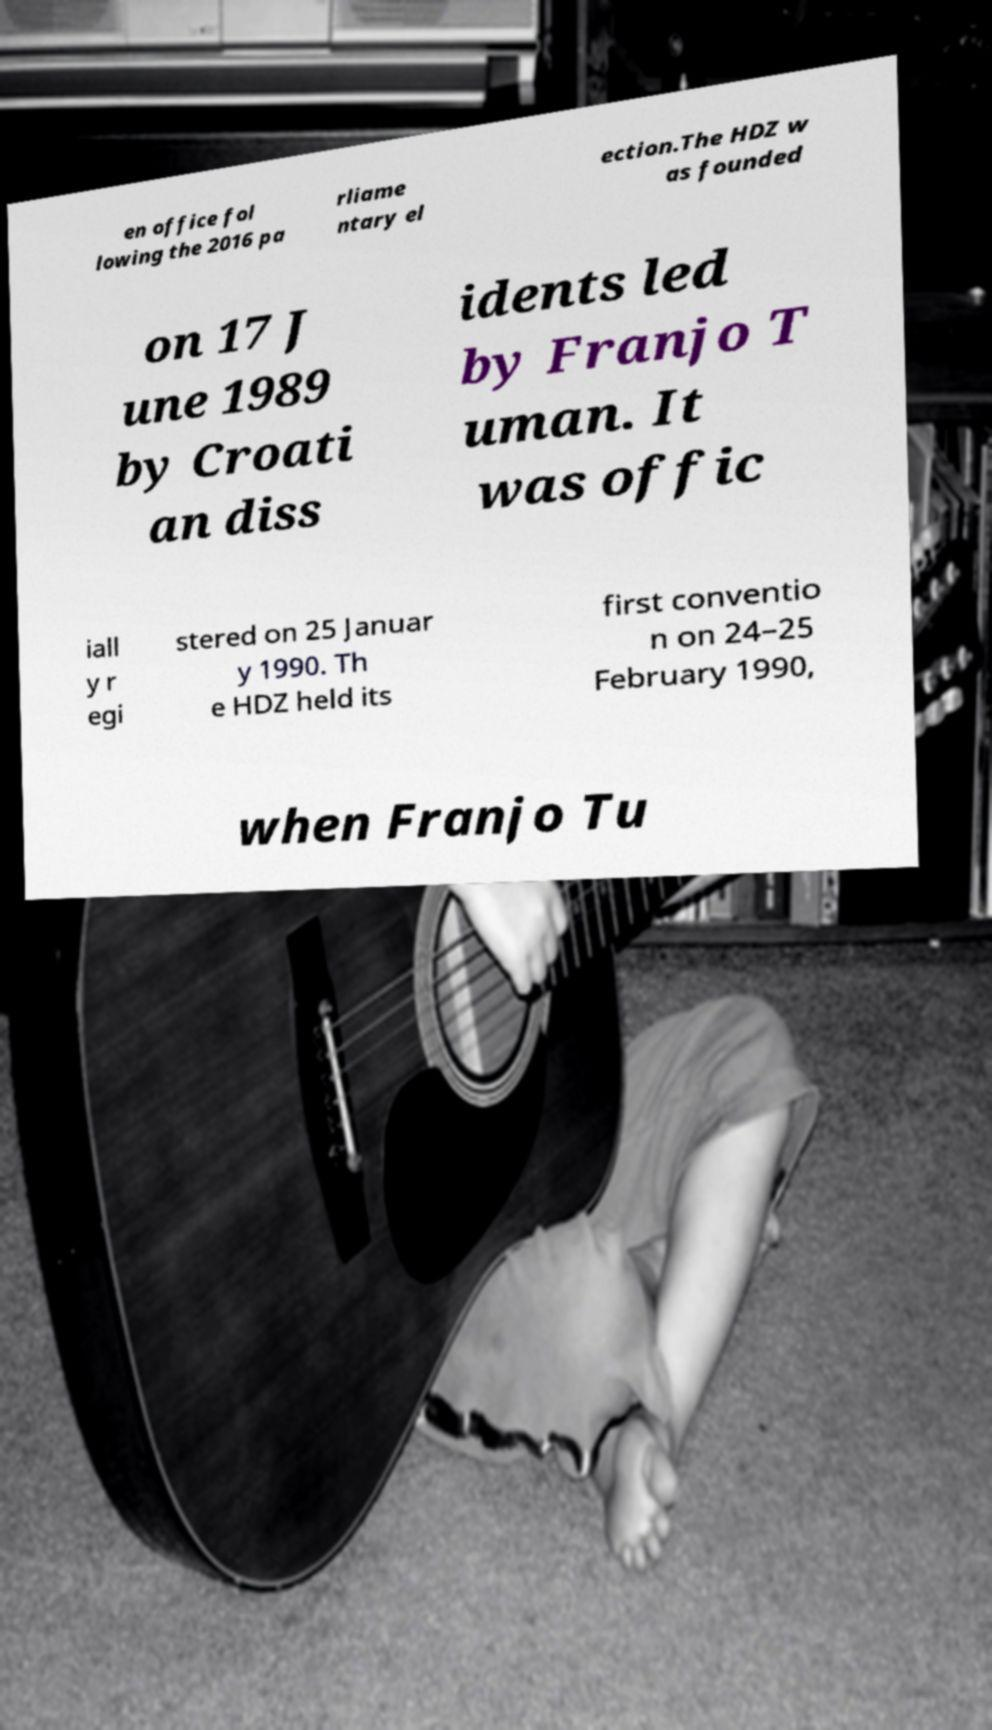Could you assist in decoding the text presented in this image and type it out clearly? en office fol lowing the 2016 pa rliame ntary el ection.The HDZ w as founded on 17 J une 1989 by Croati an diss idents led by Franjo T uman. It was offic iall y r egi stered on 25 Januar y 1990. Th e HDZ held its first conventio n on 24–25 February 1990, when Franjo Tu 